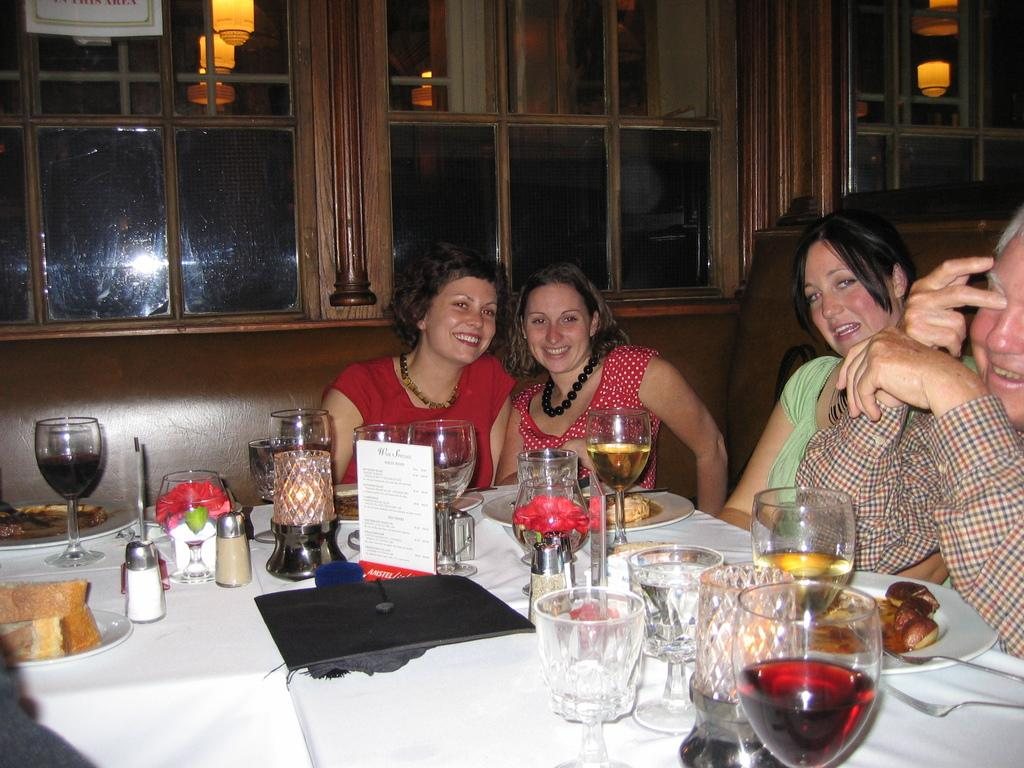How many people are present in the image? There are four people in the image. What are the people doing in the image? The people are sitting at a dining table and posing to the camera. What type of cactus can be seen on the table in the image? There is no cactus present on the table in the image. What color is the pen used by one of the people in the image? There is no pen visible in the image. 